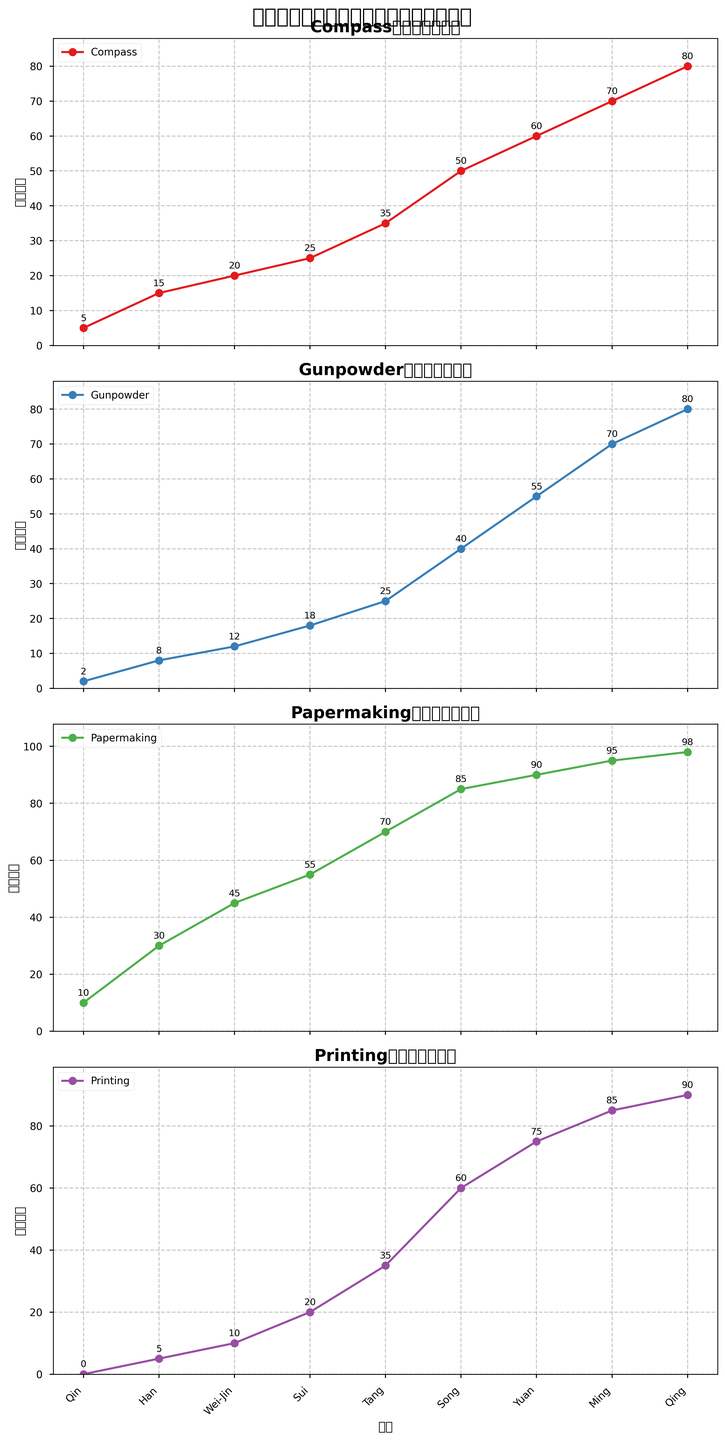Which invention shows the most significant increase in usage frequency from the Qin to the Qing dynasty? From the Qin to the Qing dynasty, the Compass increases from 5 to 80 (75 units), Gunpowder from 2 to 80 (78 units), Papermaking from 10 to 98 (88 units), and Printing from 0 to 90 (90 units). Printing shows the most significant increase.
Answer: Printing During which dynasty did Gunpowder surpass Papermaking in usage frequency? In the provided data, Gunpowder surpasses Papermaking in the Ming dynasty (70 vs 95). Before the Ming dynasty, Papermaking had higher usage than Gunpowder.
Answer: Ming What is the average usage frequency of the Compass across all dynasties? Summing the Compass frequencies across all dynasties (5 + 15 + 20 + 25 + 35 + 50 + 60 + 70 + 80 = 360) and dividing by the number of dynasties (9), the average is 360 / 9 = 40.
Answer: 40 How many dynasties have a higher usage frequency of Printing than the Han dynasty's usage frequency of Papermaking? The Han dynasty has a Papermaking frequency of 30. Printing frequencies that are higher are from the Tang (35), Song (60), Yuan (75), Ming (85), and Qing (90) dynasties.
Answer: 5 Which invention has the smallest increase in usage frequency between the Wei-Jin and Sui dynasties? The increases from Wei-Jin to Sui are: Compass (20 to 25, +5), Gunpowder (12 to 18, +6), Papermaking (45 to 55, +10), Printing (10 to 20, +10). The smallest increase is for the Compass (+5).
Answer: Compass Compare the usage frequency of Gunpowder in the Song dynasty with that of Printing in the Yuan dynasty. Which one is higher? Gunpowder in the Song dynasty is 40, and Printing in the Yuan dynasty is 75. Thus, Printing in the Yuan dynasty has a higher usage frequency.
Answer: Printing in the Yuan Which dynasty shows the highest combined usage frequency for all four inventions? Summing the frequencies for each dynasty: Qin (17), Han (58), Wei-Jin (87), Sui (118), Tang (165), Song (235), Yuan (280), Ming (320), Qing (~348). The Qing dynasty has the highest combined frequency of 348.
Answer: Qing During which two consecutive dynasties did the usage frequency of Papermaking increase the most? The usage frequency increases are: Qin to Han (+20), Han to Wei-Jin (+15), Wei-Jin to Sui (+10), Sui to Tang (+15), Tang to Song (+15), Song to Yuan (+5), Yuan to Ming (+5), Ming to Qing (+3). The greatest increase is from Han to Wei-Jin (+15).
Answer: Han to Wei-Jin 